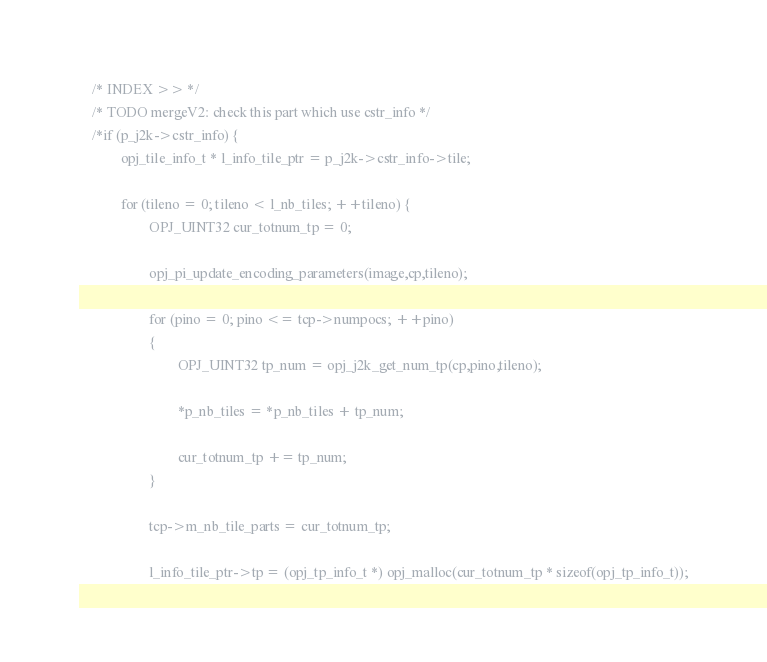<code> <loc_0><loc_0><loc_500><loc_500><_C_>    /* INDEX >> */
    /* TODO mergeV2: check this part which use cstr_info */
    /*if (p_j2k->cstr_info) {
            opj_tile_info_t * l_info_tile_ptr = p_j2k->cstr_info->tile;

            for (tileno = 0; tileno < l_nb_tiles; ++tileno) {
                    OPJ_UINT32 cur_totnum_tp = 0;

                    opj_pi_update_encoding_parameters(image,cp,tileno);

                    for (pino = 0; pino <= tcp->numpocs; ++pino)
                    {
                            OPJ_UINT32 tp_num = opj_j2k_get_num_tp(cp,pino,tileno);

                            *p_nb_tiles = *p_nb_tiles + tp_num;

                            cur_totnum_tp += tp_num;
                    }

                    tcp->m_nb_tile_parts = cur_totnum_tp;

                    l_info_tile_ptr->tp = (opj_tp_info_t *) opj_malloc(cur_totnum_tp * sizeof(opj_tp_info_t));</code> 